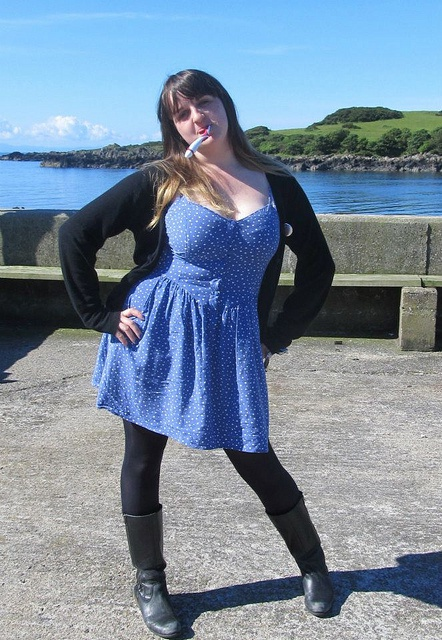Describe the objects in this image and their specific colors. I can see people in lightblue, black, navy, gray, and darkgray tones, bench in lightblue, gray, darkgray, and black tones, and toothbrush in lightblue, white, purple, and darkgray tones in this image. 